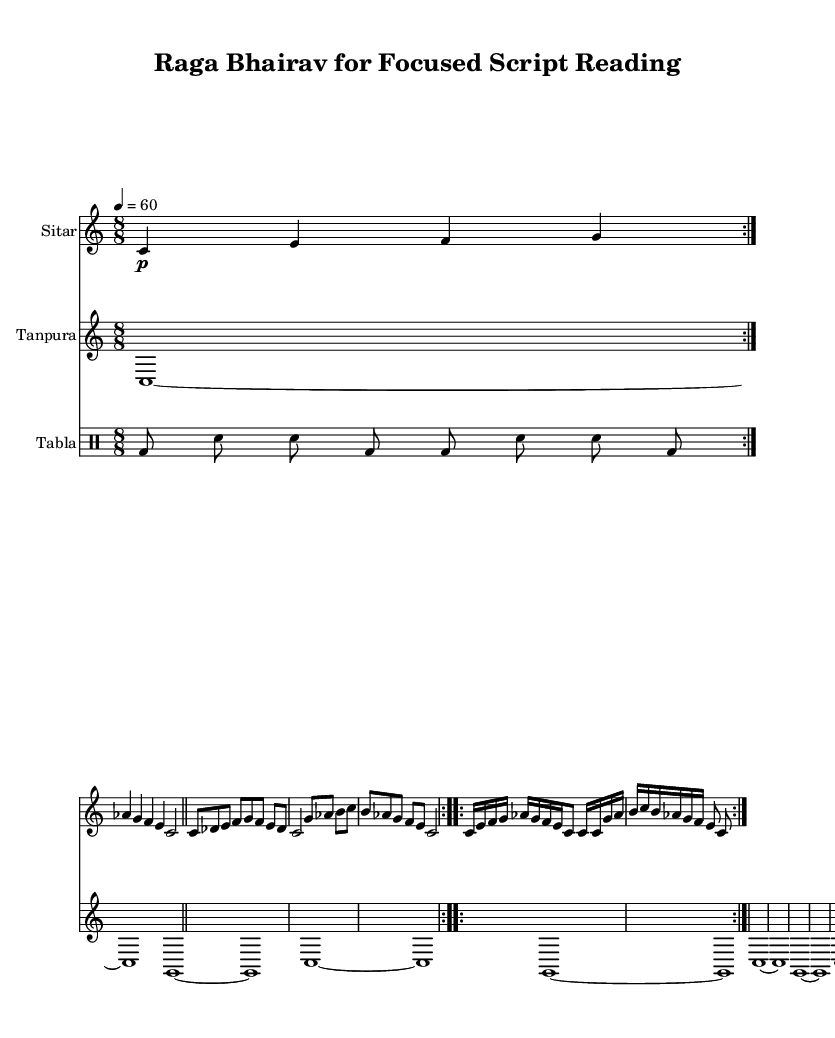What is the key signature of this music? The key signature is denoted by the presence of the B flat (the only flat indicated). The key signature can be found at the beginning of the staff.
Answer: C major What is the time signature of this music? The time signature is represented by the fraction at the beginning of the piece. In this case, it shows 8/8, indicating the rhythmic structure of the music.
Answer: 8/8 What instruments are featured in this piece? The different staves indicate the instruments being used. The first staff is for Sitar, the second for Tanpura, and the third staff is for Tabla.
Answer: Sitar, Tanpura, Tabla How many sections are present in the sitar part? The sitar part is divided into three distinct sections: Alap, Jor, and Jhala. Each section has different musical characteristics and structures.
Answer: Three What is the tempo marking for this music? The tempo marking is located at the beginning of the piece, indicating the speed at which the music should be played. The marking shows "4 = 60," where 4 is the quarter note and 60 indicates beats per minute.
Answer: 60 What rhythmic pattern is used in the tabla part? The tabla section uses a repeated rhythmic pattern that can be found in the drummode section. It consists of a sequence of strokes, with specific arrangements of bass and snare sounds.
Answer: bd8 sn sn bd bd sn sn bd What is the structural purpose of the Alap section? The Alap is a free-form section that introduces the raga without a fixed rhythm or meter, allowing for expressiveness and exploration of the raga's themes.
Answer: Exploration of the raga 